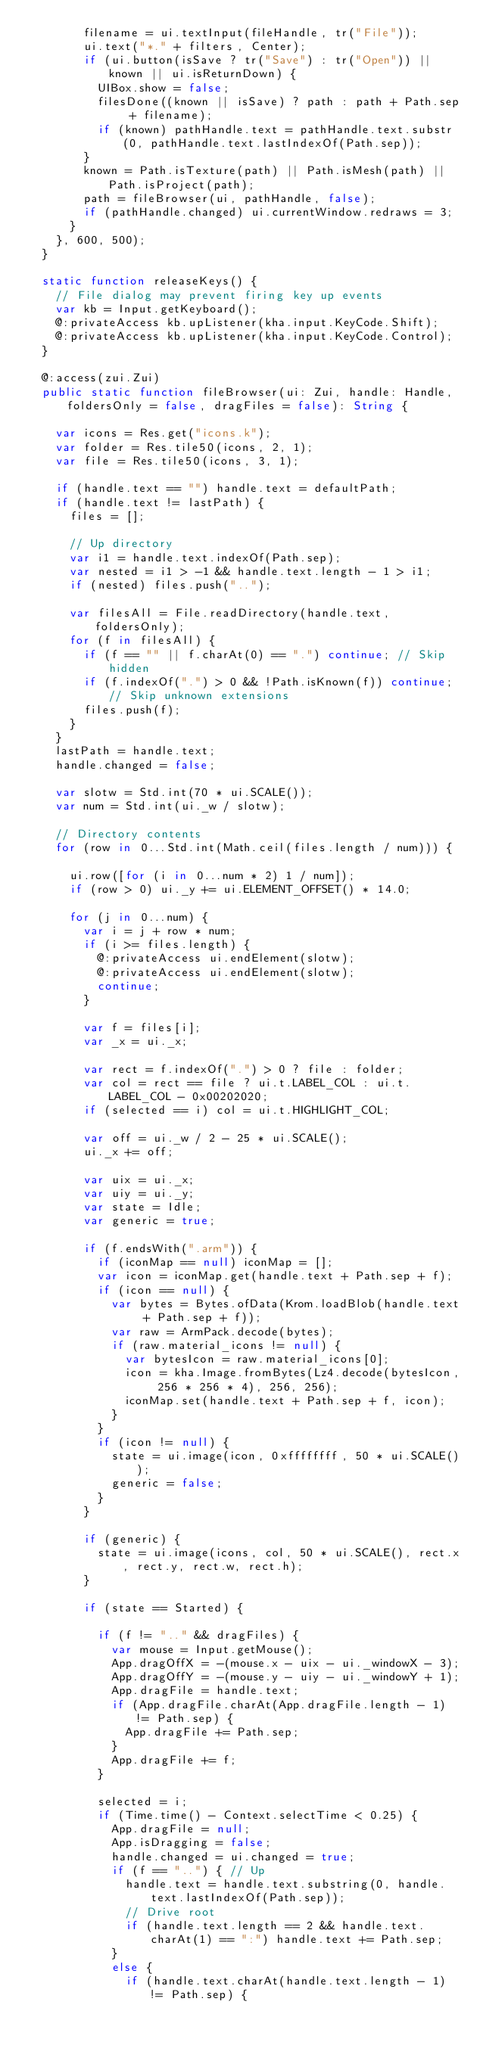<code> <loc_0><loc_0><loc_500><loc_500><_Haxe_>				filename = ui.textInput(fileHandle, tr("File"));
				ui.text("*." + filters, Center);
				if (ui.button(isSave ? tr("Save") : tr("Open")) || known || ui.isReturnDown) {
					UIBox.show = false;
					filesDone((known || isSave) ? path : path + Path.sep + filename);
					if (known) pathHandle.text = pathHandle.text.substr(0, pathHandle.text.lastIndexOf(Path.sep));
				}
				known = Path.isTexture(path) || Path.isMesh(path) || Path.isProject(path);
				path = fileBrowser(ui, pathHandle, false);
				if (pathHandle.changed) ui.currentWindow.redraws = 3;
			}
		}, 600, 500);
	}

	static function releaseKeys() {
		// File dialog may prevent firing key up events
		var kb = Input.getKeyboard();
		@:privateAccess kb.upListener(kha.input.KeyCode.Shift);
		@:privateAccess kb.upListener(kha.input.KeyCode.Control);
	}

	@:access(zui.Zui)
	public static function fileBrowser(ui: Zui, handle: Handle, foldersOnly = false, dragFiles = false): String {

		var icons = Res.get("icons.k");
		var folder = Res.tile50(icons, 2, 1);
		var file = Res.tile50(icons, 3, 1);

		if (handle.text == "") handle.text = defaultPath;
		if (handle.text != lastPath) {
			files = [];

			// Up directory
			var i1 = handle.text.indexOf(Path.sep);
			var nested = i1 > -1 && handle.text.length - 1 > i1;
			if (nested) files.push("..");

			var filesAll = File.readDirectory(handle.text, foldersOnly);
			for (f in filesAll) {
				if (f == "" || f.charAt(0) == ".") continue; // Skip hidden
				if (f.indexOf(".") > 0 && !Path.isKnown(f)) continue; // Skip unknown extensions
				files.push(f);
			}
		}
		lastPath = handle.text;
		handle.changed = false;

		var slotw = Std.int(70 * ui.SCALE());
		var num = Std.int(ui._w / slotw);

		// Directory contents
		for (row in 0...Std.int(Math.ceil(files.length / num))) {

			ui.row([for (i in 0...num * 2) 1 / num]);
			if (row > 0) ui._y += ui.ELEMENT_OFFSET() * 14.0;

			for (j in 0...num) {
				var i = j + row * num;
				if (i >= files.length) {
					@:privateAccess ui.endElement(slotw);
					@:privateAccess ui.endElement(slotw);
					continue;
				}

				var f = files[i];
				var _x = ui._x;

				var rect = f.indexOf(".") > 0 ? file : folder;
				var col = rect == file ? ui.t.LABEL_COL : ui.t.LABEL_COL - 0x00202020;
				if (selected == i) col = ui.t.HIGHLIGHT_COL;

				var off = ui._w / 2 - 25 * ui.SCALE();
				ui._x += off;

				var uix = ui._x;
				var uiy = ui._y;
				var state = Idle;
				var generic = true;

				if (f.endsWith(".arm")) {
					if (iconMap == null) iconMap = [];
					var icon = iconMap.get(handle.text + Path.sep + f);
					if (icon == null) {
						var bytes = Bytes.ofData(Krom.loadBlob(handle.text + Path.sep + f));
						var raw = ArmPack.decode(bytes);
						if (raw.material_icons != null) {
							var bytesIcon = raw.material_icons[0];
							icon = kha.Image.fromBytes(Lz4.decode(bytesIcon, 256 * 256 * 4), 256, 256);
							iconMap.set(handle.text + Path.sep + f, icon);
						}
					}
					if (icon != null) {
						state = ui.image(icon, 0xffffffff, 50 * ui.SCALE());
						generic = false;
					}
				}

				if (generic) {
					state = ui.image(icons, col, 50 * ui.SCALE(), rect.x, rect.y, rect.w, rect.h);
				}

				if (state == Started) {

					if (f != ".." && dragFiles) {
						var mouse = Input.getMouse();
						App.dragOffX = -(mouse.x - uix - ui._windowX - 3);
						App.dragOffY = -(mouse.y - uiy - ui._windowY + 1);
						App.dragFile = handle.text;
						if (App.dragFile.charAt(App.dragFile.length - 1) != Path.sep) {
							App.dragFile += Path.sep;
						}
						App.dragFile += f;
					}

					selected = i;
					if (Time.time() - Context.selectTime < 0.25) {
						App.dragFile = null;
						App.isDragging = false;
						handle.changed = ui.changed = true;
						if (f == "..") { // Up
							handle.text = handle.text.substring(0, handle.text.lastIndexOf(Path.sep));
							// Drive root
							if (handle.text.length == 2 && handle.text.charAt(1) == ":") handle.text += Path.sep;
						}
						else {
							if (handle.text.charAt(handle.text.length - 1) != Path.sep) {</code> 